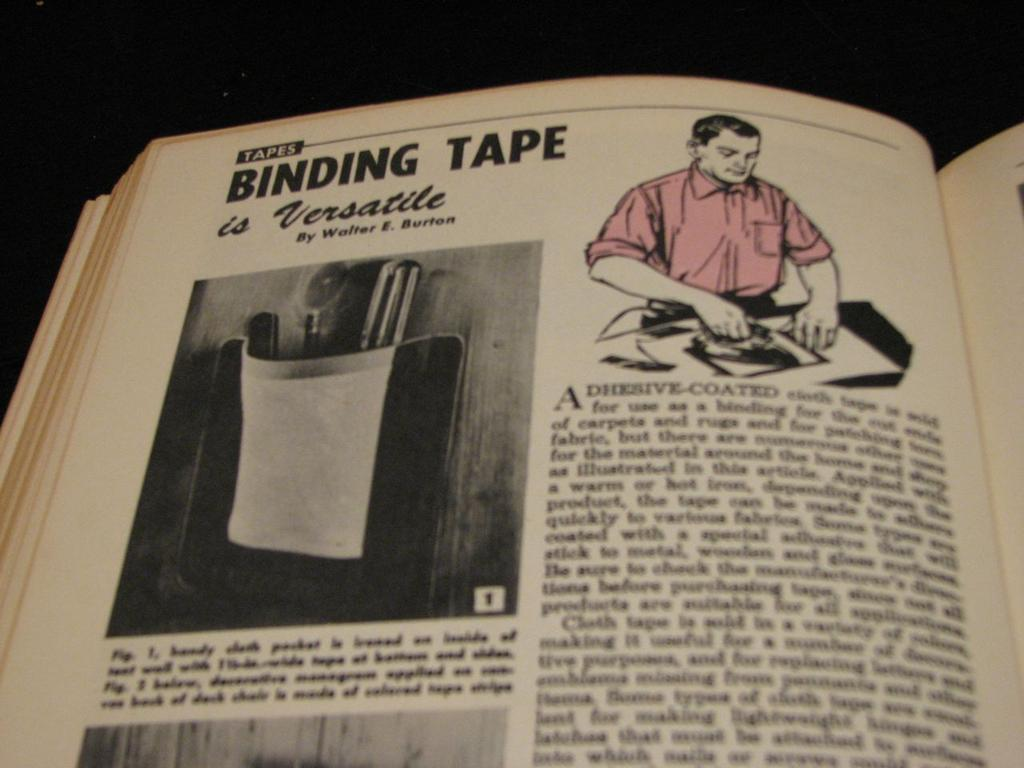Provide a one-sentence caption for the provided image. Vintage book opened to Tapes Binding Tape is Versatile with a photo and an illustration of a man using tape. 